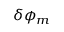<formula> <loc_0><loc_0><loc_500><loc_500>\delta \phi _ { m }</formula> 